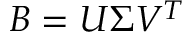<formula> <loc_0><loc_0><loc_500><loc_500>B = U \Sigma V ^ { T }</formula> 